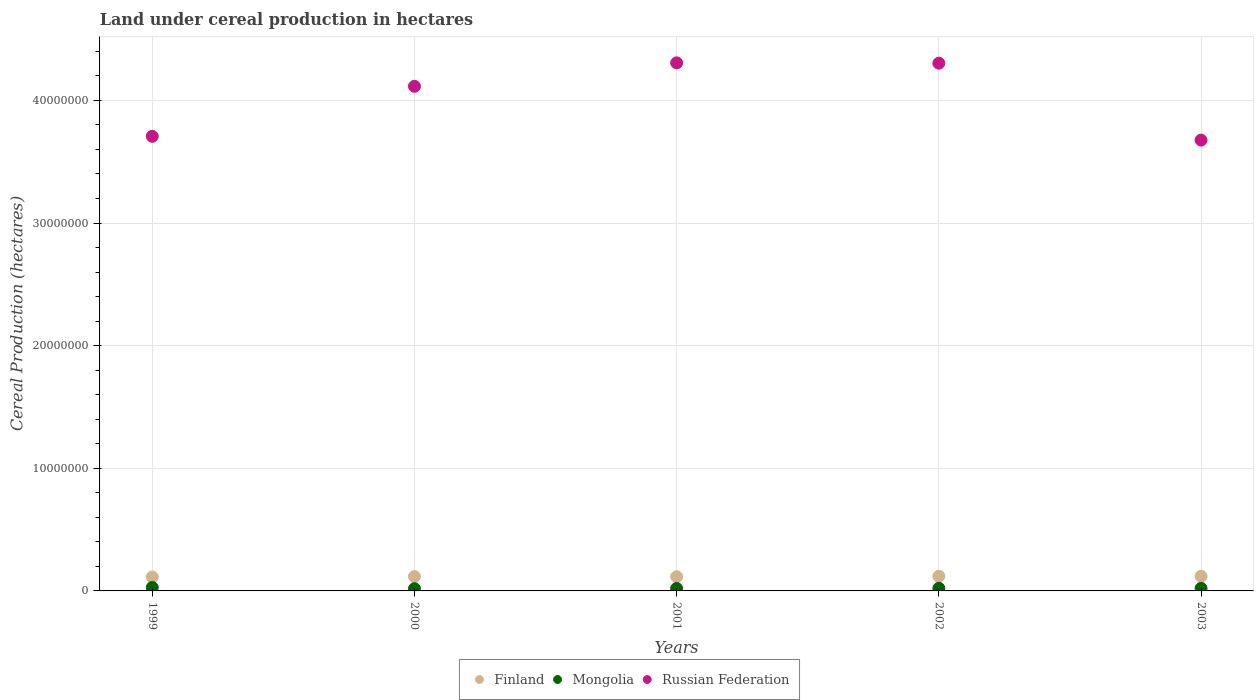What is the land under cereal production in Finland in 2003?
Ensure brevity in your answer.  1.19e+06. Across all years, what is the maximum land under cereal production in Russian Federation?
Offer a very short reply. 4.31e+07. Across all years, what is the minimum land under cereal production in Finland?
Provide a succinct answer. 1.13e+06. In which year was the land under cereal production in Mongolia maximum?
Provide a succinct answer. 1999. In which year was the land under cereal production in Mongolia minimum?
Your response must be concise. 2000. What is the total land under cereal production in Russian Federation in the graph?
Offer a terse response. 2.01e+08. What is the difference between the land under cereal production in Russian Federation in 2000 and that in 2001?
Offer a terse response. -1.91e+06. What is the difference between the land under cereal production in Russian Federation in 2002 and the land under cereal production in Finland in 2000?
Offer a very short reply. 4.19e+07. What is the average land under cereal production in Finland per year?
Ensure brevity in your answer.  1.17e+06. In the year 2002, what is the difference between the land under cereal production in Russian Federation and land under cereal production in Finland?
Your response must be concise. 4.18e+07. In how many years, is the land under cereal production in Russian Federation greater than 26000000 hectares?
Your answer should be compact. 5. What is the ratio of the land under cereal production in Russian Federation in 2001 to that in 2002?
Offer a terse response. 1. Is the difference between the land under cereal production in Russian Federation in 2001 and 2002 greater than the difference between the land under cereal production in Finland in 2001 and 2002?
Offer a very short reply. Yes. What is the difference between the highest and the second highest land under cereal production in Russian Federation?
Provide a short and direct response. 2.69e+04. What is the difference between the highest and the lowest land under cereal production in Finland?
Ensure brevity in your answer.  6.11e+04. Is it the case that in every year, the sum of the land under cereal production in Russian Federation and land under cereal production in Finland  is greater than the land under cereal production in Mongolia?
Offer a very short reply. Yes. Does the land under cereal production in Finland monotonically increase over the years?
Offer a very short reply. No. Is the land under cereal production in Mongolia strictly greater than the land under cereal production in Russian Federation over the years?
Give a very brief answer. No. How many years are there in the graph?
Make the answer very short. 5. Does the graph contain any zero values?
Make the answer very short. No. Where does the legend appear in the graph?
Make the answer very short. Bottom center. How many legend labels are there?
Keep it short and to the point. 3. How are the legend labels stacked?
Provide a short and direct response. Horizontal. What is the title of the graph?
Offer a very short reply. Land under cereal production in hectares. What is the label or title of the X-axis?
Offer a very short reply. Years. What is the label or title of the Y-axis?
Your answer should be compact. Cereal Production (hectares). What is the Cereal Production (hectares) of Finland in 1999?
Offer a very short reply. 1.13e+06. What is the Cereal Production (hectares) in Mongolia in 1999?
Give a very brief answer. 2.79e+05. What is the Cereal Production (hectares) in Russian Federation in 1999?
Provide a succinct answer. 3.71e+07. What is the Cereal Production (hectares) in Finland in 2000?
Provide a succinct answer. 1.17e+06. What is the Cereal Production (hectares) in Mongolia in 2000?
Make the answer very short. 1.83e+05. What is the Cereal Production (hectares) of Russian Federation in 2000?
Give a very brief answer. 4.11e+07. What is the Cereal Production (hectares) in Finland in 2001?
Provide a succinct answer. 1.16e+06. What is the Cereal Production (hectares) of Mongolia in 2001?
Ensure brevity in your answer.  2.00e+05. What is the Cereal Production (hectares) of Russian Federation in 2001?
Give a very brief answer. 4.31e+07. What is the Cereal Production (hectares) of Finland in 2002?
Offer a very short reply. 1.20e+06. What is the Cereal Production (hectares) of Mongolia in 2002?
Offer a terse response. 2.14e+05. What is the Cereal Production (hectares) of Russian Federation in 2002?
Offer a terse response. 4.30e+07. What is the Cereal Production (hectares) of Finland in 2003?
Your answer should be compact. 1.19e+06. What is the Cereal Production (hectares) of Mongolia in 2003?
Offer a very short reply. 2.07e+05. What is the Cereal Production (hectares) of Russian Federation in 2003?
Provide a short and direct response. 3.68e+07. Across all years, what is the maximum Cereal Production (hectares) of Finland?
Keep it short and to the point. 1.20e+06. Across all years, what is the maximum Cereal Production (hectares) of Mongolia?
Offer a very short reply. 2.79e+05. Across all years, what is the maximum Cereal Production (hectares) of Russian Federation?
Make the answer very short. 4.31e+07. Across all years, what is the minimum Cereal Production (hectares) in Finland?
Provide a short and direct response. 1.13e+06. Across all years, what is the minimum Cereal Production (hectares) of Mongolia?
Make the answer very short. 1.83e+05. Across all years, what is the minimum Cereal Production (hectares) in Russian Federation?
Your answer should be compact. 3.68e+07. What is the total Cereal Production (hectares) in Finland in the graph?
Offer a terse response. 5.85e+06. What is the total Cereal Production (hectares) in Mongolia in the graph?
Make the answer very short. 1.08e+06. What is the total Cereal Production (hectares) of Russian Federation in the graph?
Make the answer very short. 2.01e+08. What is the difference between the Cereal Production (hectares) of Finland in 1999 and that in 2000?
Keep it short and to the point. -3.87e+04. What is the difference between the Cereal Production (hectares) of Mongolia in 1999 and that in 2000?
Give a very brief answer. 9.57e+04. What is the difference between the Cereal Production (hectares) in Russian Federation in 1999 and that in 2000?
Ensure brevity in your answer.  -4.08e+06. What is the difference between the Cereal Production (hectares) in Finland in 1999 and that in 2001?
Your answer should be compact. -2.62e+04. What is the difference between the Cereal Production (hectares) of Mongolia in 1999 and that in 2001?
Give a very brief answer. 7.96e+04. What is the difference between the Cereal Production (hectares) of Russian Federation in 1999 and that in 2001?
Make the answer very short. -5.99e+06. What is the difference between the Cereal Production (hectares) in Finland in 1999 and that in 2002?
Provide a succinct answer. -6.11e+04. What is the difference between the Cereal Production (hectares) in Mongolia in 1999 and that in 2002?
Make the answer very short. 6.51e+04. What is the difference between the Cereal Production (hectares) in Russian Federation in 1999 and that in 2002?
Offer a very short reply. -5.96e+06. What is the difference between the Cereal Production (hectares) in Finland in 1999 and that in 2003?
Ensure brevity in your answer.  -5.89e+04. What is the difference between the Cereal Production (hectares) in Mongolia in 1999 and that in 2003?
Ensure brevity in your answer.  7.23e+04. What is the difference between the Cereal Production (hectares) in Russian Federation in 1999 and that in 2003?
Provide a succinct answer. 3.10e+05. What is the difference between the Cereal Production (hectares) of Finland in 2000 and that in 2001?
Provide a succinct answer. 1.25e+04. What is the difference between the Cereal Production (hectares) in Mongolia in 2000 and that in 2001?
Your response must be concise. -1.61e+04. What is the difference between the Cereal Production (hectares) in Russian Federation in 2000 and that in 2001?
Make the answer very short. -1.91e+06. What is the difference between the Cereal Production (hectares) of Finland in 2000 and that in 2002?
Offer a terse response. -2.24e+04. What is the difference between the Cereal Production (hectares) of Mongolia in 2000 and that in 2002?
Keep it short and to the point. -3.06e+04. What is the difference between the Cereal Production (hectares) in Russian Federation in 2000 and that in 2002?
Provide a short and direct response. -1.89e+06. What is the difference between the Cereal Production (hectares) in Finland in 2000 and that in 2003?
Provide a succinct answer. -2.02e+04. What is the difference between the Cereal Production (hectares) of Mongolia in 2000 and that in 2003?
Offer a terse response. -2.34e+04. What is the difference between the Cereal Production (hectares) in Russian Federation in 2000 and that in 2003?
Make the answer very short. 4.39e+06. What is the difference between the Cereal Production (hectares) of Finland in 2001 and that in 2002?
Give a very brief answer. -3.49e+04. What is the difference between the Cereal Production (hectares) of Mongolia in 2001 and that in 2002?
Your answer should be very brief. -1.45e+04. What is the difference between the Cereal Production (hectares) in Russian Federation in 2001 and that in 2002?
Make the answer very short. 2.69e+04. What is the difference between the Cereal Production (hectares) of Finland in 2001 and that in 2003?
Your answer should be compact. -3.27e+04. What is the difference between the Cereal Production (hectares) of Mongolia in 2001 and that in 2003?
Offer a terse response. -7307. What is the difference between the Cereal Production (hectares) of Russian Federation in 2001 and that in 2003?
Your response must be concise. 6.30e+06. What is the difference between the Cereal Production (hectares) in Finland in 2002 and that in 2003?
Offer a very short reply. 2200. What is the difference between the Cereal Production (hectares) of Mongolia in 2002 and that in 2003?
Offer a very short reply. 7206. What is the difference between the Cereal Production (hectares) of Russian Federation in 2002 and that in 2003?
Offer a terse response. 6.27e+06. What is the difference between the Cereal Production (hectares) in Finland in 1999 and the Cereal Production (hectares) in Mongolia in 2000?
Keep it short and to the point. 9.51e+05. What is the difference between the Cereal Production (hectares) in Finland in 1999 and the Cereal Production (hectares) in Russian Federation in 2000?
Ensure brevity in your answer.  -4.00e+07. What is the difference between the Cereal Production (hectares) in Mongolia in 1999 and the Cereal Production (hectares) in Russian Federation in 2000?
Keep it short and to the point. -4.09e+07. What is the difference between the Cereal Production (hectares) of Finland in 1999 and the Cereal Production (hectares) of Mongolia in 2001?
Ensure brevity in your answer.  9.34e+05. What is the difference between the Cereal Production (hectares) in Finland in 1999 and the Cereal Production (hectares) in Russian Federation in 2001?
Your answer should be very brief. -4.19e+07. What is the difference between the Cereal Production (hectares) in Mongolia in 1999 and the Cereal Production (hectares) in Russian Federation in 2001?
Provide a short and direct response. -4.28e+07. What is the difference between the Cereal Production (hectares) of Finland in 1999 and the Cereal Production (hectares) of Mongolia in 2002?
Provide a short and direct response. 9.20e+05. What is the difference between the Cereal Production (hectares) in Finland in 1999 and the Cereal Production (hectares) in Russian Federation in 2002?
Your response must be concise. -4.19e+07. What is the difference between the Cereal Production (hectares) of Mongolia in 1999 and the Cereal Production (hectares) of Russian Federation in 2002?
Your response must be concise. -4.28e+07. What is the difference between the Cereal Production (hectares) of Finland in 1999 and the Cereal Production (hectares) of Mongolia in 2003?
Offer a terse response. 9.27e+05. What is the difference between the Cereal Production (hectares) in Finland in 1999 and the Cereal Production (hectares) in Russian Federation in 2003?
Provide a succinct answer. -3.56e+07. What is the difference between the Cereal Production (hectares) in Mongolia in 1999 and the Cereal Production (hectares) in Russian Federation in 2003?
Your answer should be compact. -3.65e+07. What is the difference between the Cereal Production (hectares) of Finland in 2000 and the Cereal Production (hectares) of Mongolia in 2001?
Keep it short and to the point. 9.73e+05. What is the difference between the Cereal Production (hectares) in Finland in 2000 and the Cereal Production (hectares) in Russian Federation in 2001?
Keep it short and to the point. -4.19e+07. What is the difference between the Cereal Production (hectares) in Mongolia in 2000 and the Cereal Production (hectares) in Russian Federation in 2001?
Give a very brief answer. -4.29e+07. What is the difference between the Cereal Production (hectares) in Finland in 2000 and the Cereal Production (hectares) in Mongolia in 2002?
Make the answer very short. 9.59e+05. What is the difference between the Cereal Production (hectares) in Finland in 2000 and the Cereal Production (hectares) in Russian Federation in 2002?
Give a very brief answer. -4.19e+07. What is the difference between the Cereal Production (hectares) in Mongolia in 2000 and the Cereal Production (hectares) in Russian Federation in 2002?
Your response must be concise. -4.28e+07. What is the difference between the Cereal Production (hectares) of Finland in 2000 and the Cereal Production (hectares) of Mongolia in 2003?
Provide a succinct answer. 9.66e+05. What is the difference between the Cereal Production (hectares) in Finland in 2000 and the Cereal Production (hectares) in Russian Federation in 2003?
Give a very brief answer. -3.56e+07. What is the difference between the Cereal Production (hectares) in Mongolia in 2000 and the Cereal Production (hectares) in Russian Federation in 2003?
Keep it short and to the point. -3.66e+07. What is the difference between the Cereal Production (hectares) of Finland in 2001 and the Cereal Production (hectares) of Mongolia in 2002?
Make the answer very short. 9.46e+05. What is the difference between the Cereal Production (hectares) in Finland in 2001 and the Cereal Production (hectares) in Russian Federation in 2002?
Offer a very short reply. -4.19e+07. What is the difference between the Cereal Production (hectares) of Mongolia in 2001 and the Cereal Production (hectares) of Russian Federation in 2002?
Provide a succinct answer. -4.28e+07. What is the difference between the Cereal Production (hectares) of Finland in 2001 and the Cereal Production (hectares) of Mongolia in 2003?
Ensure brevity in your answer.  9.53e+05. What is the difference between the Cereal Production (hectares) in Finland in 2001 and the Cereal Production (hectares) in Russian Federation in 2003?
Offer a very short reply. -3.56e+07. What is the difference between the Cereal Production (hectares) of Mongolia in 2001 and the Cereal Production (hectares) of Russian Federation in 2003?
Provide a succinct answer. -3.66e+07. What is the difference between the Cereal Production (hectares) of Finland in 2002 and the Cereal Production (hectares) of Mongolia in 2003?
Ensure brevity in your answer.  9.88e+05. What is the difference between the Cereal Production (hectares) in Finland in 2002 and the Cereal Production (hectares) in Russian Federation in 2003?
Give a very brief answer. -3.56e+07. What is the difference between the Cereal Production (hectares) in Mongolia in 2002 and the Cereal Production (hectares) in Russian Federation in 2003?
Keep it short and to the point. -3.65e+07. What is the average Cereal Production (hectares) of Finland per year?
Make the answer very short. 1.17e+06. What is the average Cereal Production (hectares) of Mongolia per year?
Give a very brief answer. 2.17e+05. What is the average Cereal Production (hectares) of Russian Federation per year?
Your response must be concise. 4.02e+07. In the year 1999, what is the difference between the Cereal Production (hectares) of Finland and Cereal Production (hectares) of Mongolia?
Your answer should be compact. 8.55e+05. In the year 1999, what is the difference between the Cereal Production (hectares) of Finland and Cereal Production (hectares) of Russian Federation?
Your answer should be compact. -3.59e+07. In the year 1999, what is the difference between the Cereal Production (hectares) of Mongolia and Cereal Production (hectares) of Russian Federation?
Your answer should be compact. -3.68e+07. In the year 2000, what is the difference between the Cereal Production (hectares) in Finland and Cereal Production (hectares) in Mongolia?
Offer a very short reply. 9.89e+05. In the year 2000, what is the difference between the Cereal Production (hectares) of Finland and Cereal Production (hectares) of Russian Federation?
Your answer should be very brief. -4.00e+07. In the year 2000, what is the difference between the Cereal Production (hectares) of Mongolia and Cereal Production (hectares) of Russian Federation?
Your answer should be very brief. -4.10e+07. In the year 2001, what is the difference between the Cereal Production (hectares) in Finland and Cereal Production (hectares) in Mongolia?
Ensure brevity in your answer.  9.61e+05. In the year 2001, what is the difference between the Cereal Production (hectares) of Finland and Cereal Production (hectares) of Russian Federation?
Your response must be concise. -4.19e+07. In the year 2001, what is the difference between the Cereal Production (hectares) in Mongolia and Cereal Production (hectares) in Russian Federation?
Offer a terse response. -4.29e+07. In the year 2002, what is the difference between the Cereal Production (hectares) in Finland and Cereal Production (hectares) in Mongolia?
Offer a very short reply. 9.81e+05. In the year 2002, what is the difference between the Cereal Production (hectares) in Finland and Cereal Production (hectares) in Russian Federation?
Make the answer very short. -4.18e+07. In the year 2002, what is the difference between the Cereal Production (hectares) of Mongolia and Cereal Production (hectares) of Russian Federation?
Your answer should be compact. -4.28e+07. In the year 2003, what is the difference between the Cereal Production (hectares) in Finland and Cereal Production (hectares) in Mongolia?
Offer a terse response. 9.86e+05. In the year 2003, what is the difference between the Cereal Production (hectares) in Finland and Cereal Production (hectares) in Russian Federation?
Offer a terse response. -3.56e+07. In the year 2003, what is the difference between the Cereal Production (hectares) of Mongolia and Cereal Production (hectares) of Russian Federation?
Give a very brief answer. -3.66e+07. What is the ratio of the Cereal Production (hectares) in Finland in 1999 to that in 2000?
Keep it short and to the point. 0.97. What is the ratio of the Cereal Production (hectares) of Mongolia in 1999 to that in 2000?
Your answer should be very brief. 1.52. What is the ratio of the Cereal Production (hectares) in Russian Federation in 1999 to that in 2000?
Offer a terse response. 0.9. What is the ratio of the Cereal Production (hectares) of Finland in 1999 to that in 2001?
Your answer should be compact. 0.98. What is the ratio of the Cereal Production (hectares) in Mongolia in 1999 to that in 2001?
Provide a short and direct response. 1.4. What is the ratio of the Cereal Production (hectares) in Russian Federation in 1999 to that in 2001?
Your answer should be compact. 0.86. What is the ratio of the Cereal Production (hectares) in Finland in 1999 to that in 2002?
Your answer should be compact. 0.95. What is the ratio of the Cereal Production (hectares) of Mongolia in 1999 to that in 2002?
Offer a terse response. 1.3. What is the ratio of the Cereal Production (hectares) of Russian Federation in 1999 to that in 2002?
Make the answer very short. 0.86. What is the ratio of the Cereal Production (hectares) of Finland in 1999 to that in 2003?
Your answer should be compact. 0.95. What is the ratio of the Cereal Production (hectares) of Mongolia in 1999 to that in 2003?
Offer a very short reply. 1.35. What is the ratio of the Cereal Production (hectares) of Russian Federation in 1999 to that in 2003?
Make the answer very short. 1.01. What is the ratio of the Cereal Production (hectares) of Finland in 2000 to that in 2001?
Your answer should be compact. 1.01. What is the ratio of the Cereal Production (hectares) in Mongolia in 2000 to that in 2001?
Make the answer very short. 0.92. What is the ratio of the Cereal Production (hectares) of Russian Federation in 2000 to that in 2001?
Your answer should be very brief. 0.96. What is the ratio of the Cereal Production (hectares) in Finland in 2000 to that in 2002?
Offer a very short reply. 0.98. What is the ratio of the Cereal Production (hectares) in Mongolia in 2000 to that in 2002?
Give a very brief answer. 0.86. What is the ratio of the Cereal Production (hectares) of Russian Federation in 2000 to that in 2002?
Your answer should be compact. 0.96. What is the ratio of the Cereal Production (hectares) of Finland in 2000 to that in 2003?
Make the answer very short. 0.98. What is the ratio of the Cereal Production (hectares) of Mongolia in 2000 to that in 2003?
Provide a succinct answer. 0.89. What is the ratio of the Cereal Production (hectares) in Russian Federation in 2000 to that in 2003?
Offer a very short reply. 1.12. What is the ratio of the Cereal Production (hectares) of Finland in 2001 to that in 2002?
Provide a succinct answer. 0.97. What is the ratio of the Cereal Production (hectares) of Mongolia in 2001 to that in 2002?
Offer a terse response. 0.93. What is the ratio of the Cereal Production (hectares) of Finland in 2001 to that in 2003?
Your answer should be very brief. 0.97. What is the ratio of the Cereal Production (hectares) in Mongolia in 2001 to that in 2003?
Provide a short and direct response. 0.96. What is the ratio of the Cereal Production (hectares) in Russian Federation in 2001 to that in 2003?
Provide a succinct answer. 1.17. What is the ratio of the Cereal Production (hectares) in Mongolia in 2002 to that in 2003?
Your response must be concise. 1.03. What is the ratio of the Cereal Production (hectares) in Russian Federation in 2002 to that in 2003?
Provide a succinct answer. 1.17. What is the difference between the highest and the second highest Cereal Production (hectares) in Finland?
Provide a short and direct response. 2200. What is the difference between the highest and the second highest Cereal Production (hectares) in Mongolia?
Keep it short and to the point. 6.51e+04. What is the difference between the highest and the second highest Cereal Production (hectares) of Russian Federation?
Make the answer very short. 2.69e+04. What is the difference between the highest and the lowest Cereal Production (hectares) in Finland?
Offer a terse response. 6.11e+04. What is the difference between the highest and the lowest Cereal Production (hectares) in Mongolia?
Keep it short and to the point. 9.57e+04. What is the difference between the highest and the lowest Cereal Production (hectares) of Russian Federation?
Provide a short and direct response. 6.30e+06. 